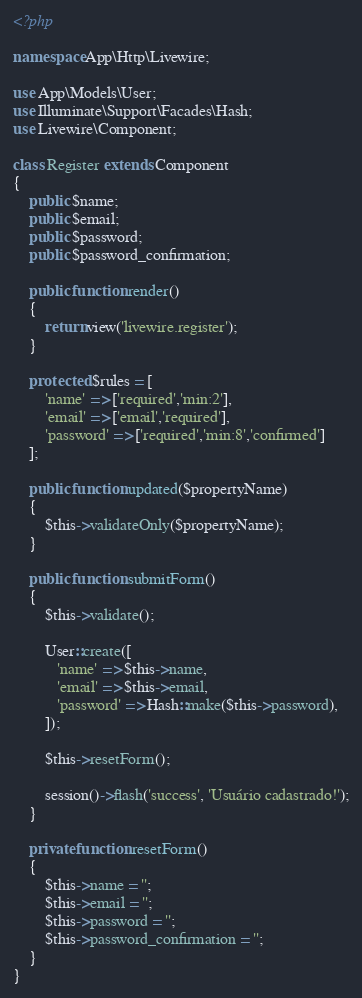Convert code to text. <code><loc_0><loc_0><loc_500><loc_500><_PHP_><?php

namespace App\Http\Livewire;

use App\Models\User;
use Illuminate\Support\Facades\Hash;
use Livewire\Component;

class Register extends Component
{
    public $name;
    public $email;
    public $password;
    public $password_confirmation;

    public function render()
    {
        return view('livewire.register');
    }

    protected $rules = [
        'name' => ['required','min:2'],
        'email' => ['email','required'],
        'password' => ['required','min:8','confirmed']
    ];

    public function updated($propertyName)
    {
        $this->validateOnly($propertyName);
    }

    public function submitForm()
    {
        $this->validate();

        User::create([
           'name' => $this->name,
           'email' => $this->email,
           'password' => Hash::make($this->password),
        ]);

        $this->resetForm();

        session()->flash('success', 'Usuário cadastrado!');
    }

    private function resetForm()
    {
        $this->name = '';
        $this->email = '';
        $this->password = '';
        $this->password_confirmation = '';
    }
}
</code> 